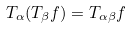<formula> <loc_0><loc_0><loc_500><loc_500>T _ { \alpha } ( T _ { \beta } f ) = T _ { \alpha \beta } f</formula> 